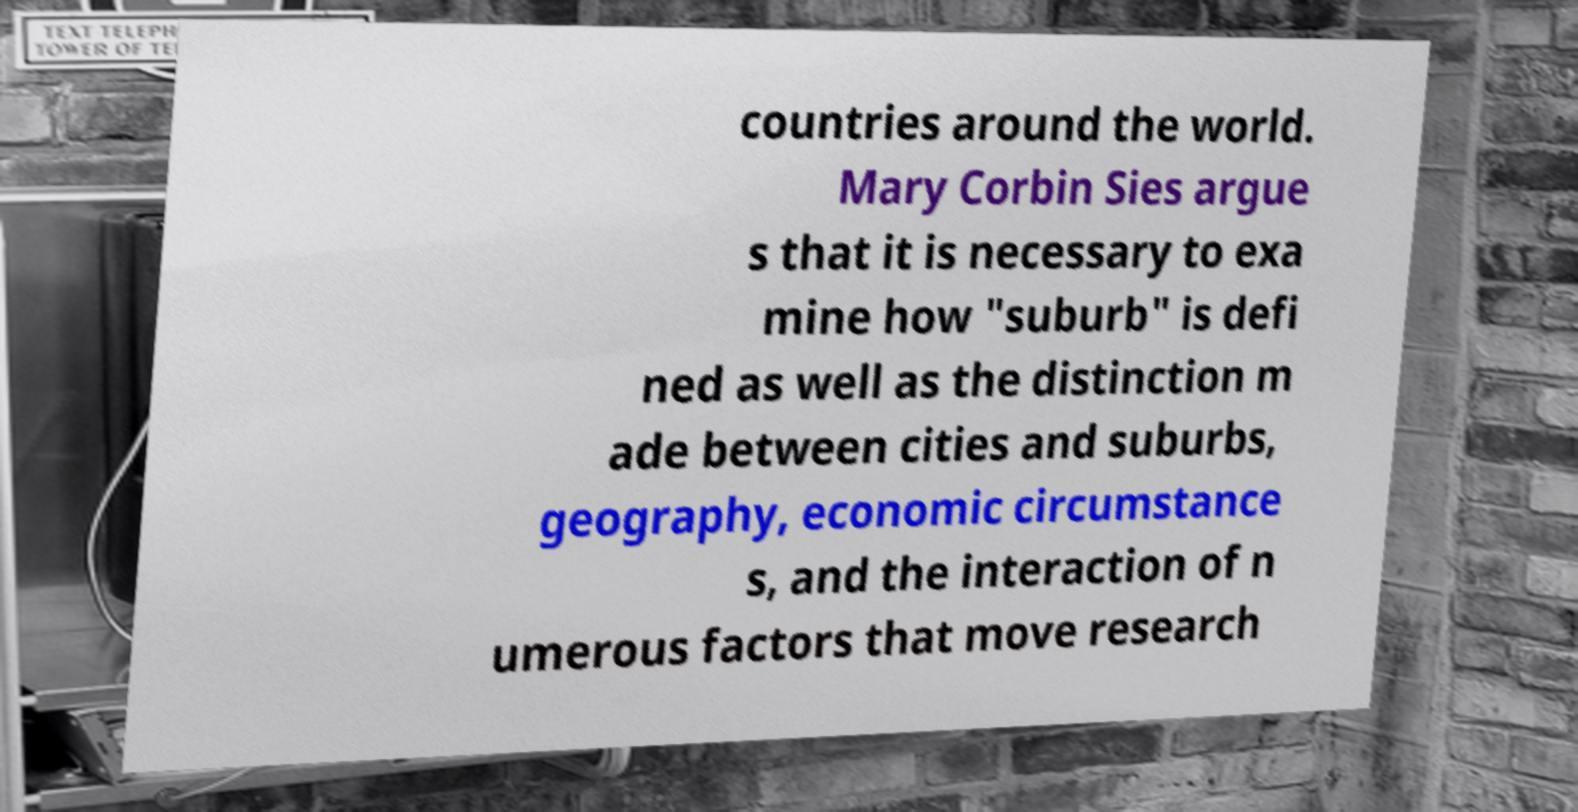Can you read and provide the text displayed in the image?This photo seems to have some interesting text. Can you extract and type it out for me? countries around the world. Mary Corbin Sies argue s that it is necessary to exa mine how "suburb" is defi ned as well as the distinction m ade between cities and suburbs, geography, economic circumstance s, and the interaction of n umerous factors that move research 